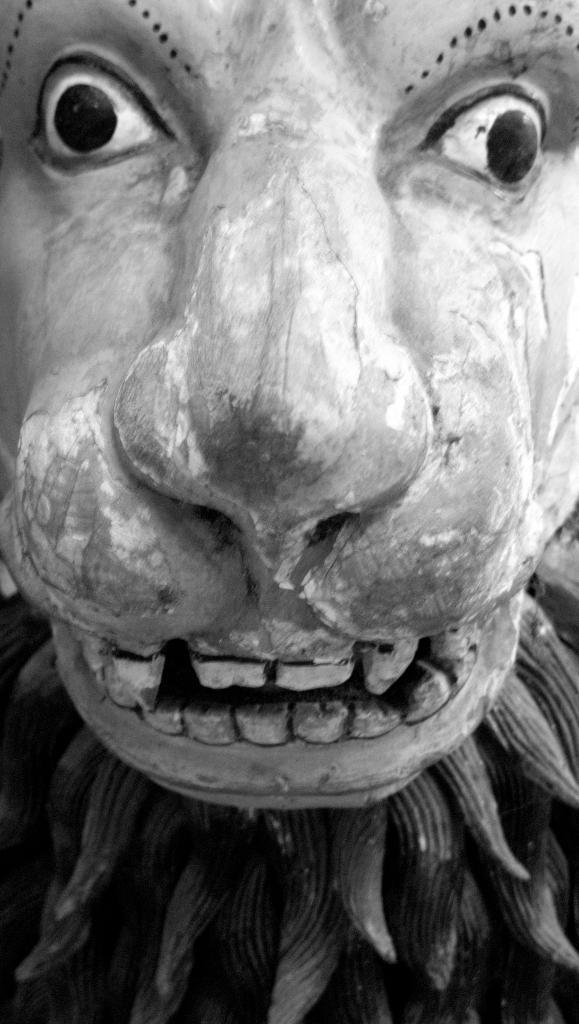Can you describe this image briefly? This is a black and white image and here we can see a sculpture. 